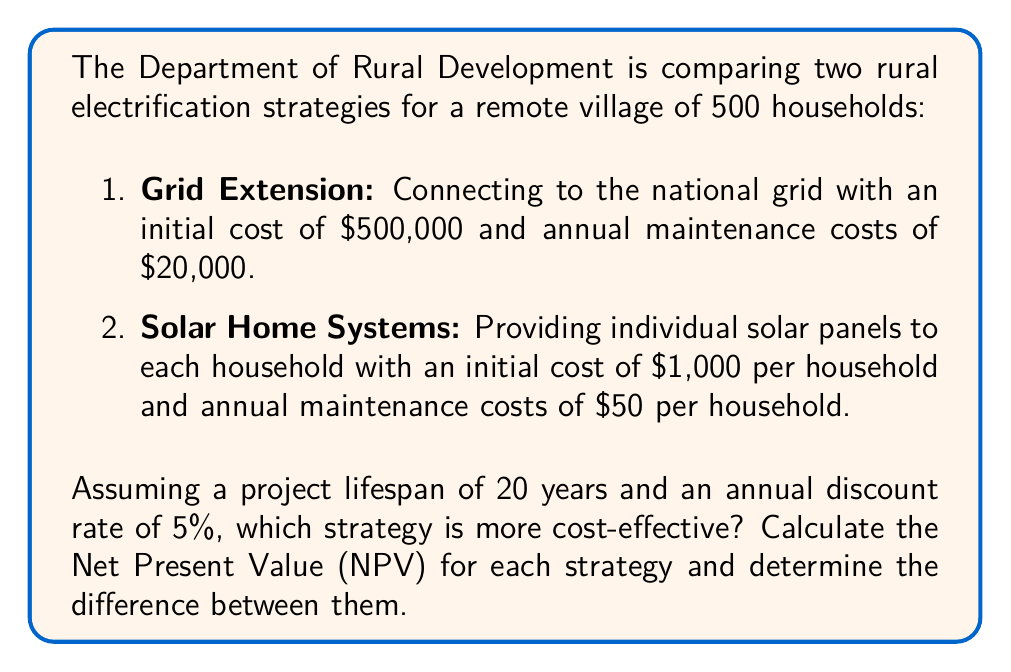What is the answer to this math problem? To solve this problem, we need to calculate the Net Present Value (NPV) for each strategy over the 20-year lifespan. We'll use the NPV formula:

$$ NPV = -C_0 + \sum_{t=1}^{T} \frac{C_t}{(1+r)^t} $$

Where:
$C_0$ = Initial cost
$C_t$ = Annual cost at year t
$r$ = Discount rate
$T$ = Project lifespan

1. Grid Extension Strategy:
Initial cost: $C_0 = \$500,000$
Annual cost: $C_t = \$20,000$ for all t

$$ NPV_{grid} = -500,000 + \sum_{t=1}^{20} \frac{20,000}{(1+0.05)^t} $$

2. Solar Home Systems Strategy:
Initial cost: $C_0 = 500 \times \$1,000 = \$500,000$
Annual cost: $C_t = 500 \times \$50 = \$25,000$ for all t

$$ NPV_{solar} = -500,000 + \sum_{t=1}^{20} \frac{25,000}{(1+0.05)^t} $$

To calculate these sums, we can use the present value annuity formula:

$$ PV_{annuity} = A \times \frac{1 - (1+r)^{-T}}{r} $$

Where A is the annual payment.

For Grid Extension:
$$ NPV_{grid} = -500,000 + 20,000 \times \frac{1 - (1+0.05)^{-20}}{0.05} = -500,000 + 20,000 \times 12.4622 = -250,756 $$

For Solar Home Systems:
$$ NPV_{solar} = -500,000 + 25,000 \times \frac{1 - (1+0.05)^{-20}}{0.05} = -500,000 + 25,000 \times 12.4622 = -188,445 $$

The difference between the two NPVs:
$$ NPV_{solar} - NPV_{grid} = -188,445 - (-250,756) = 62,311 $$
Answer: The Solar Home Systems strategy is more cost-effective with an NPV of $-188,445, which is $62,311 better than the Grid Extension strategy's NPV of $-250,756. 